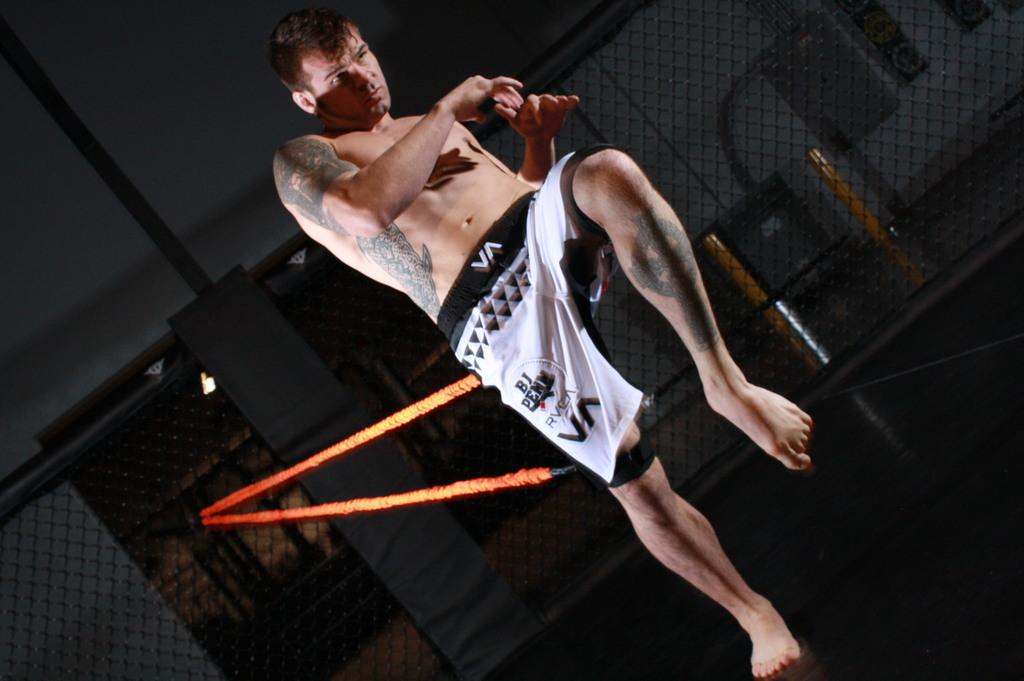<image>
Write a terse but informative summary of the picture. A kickboxer training with some shorts that say BJ on it 